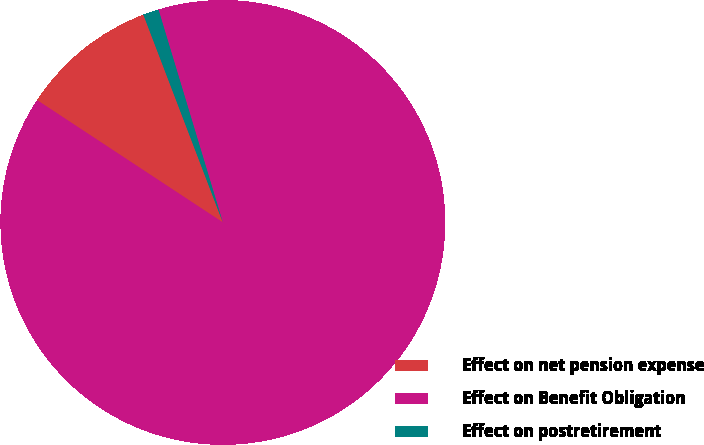Convert chart to OTSL. <chart><loc_0><loc_0><loc_500><loc_500><pie_chart><fcel>Effect on net pension expense<fcel>Effect on Benefit Obligation<fcel>Effect on postretirement<nl><fcel>9.92%<fcel>88.94%<fcel>1.14%<nl></chart> 